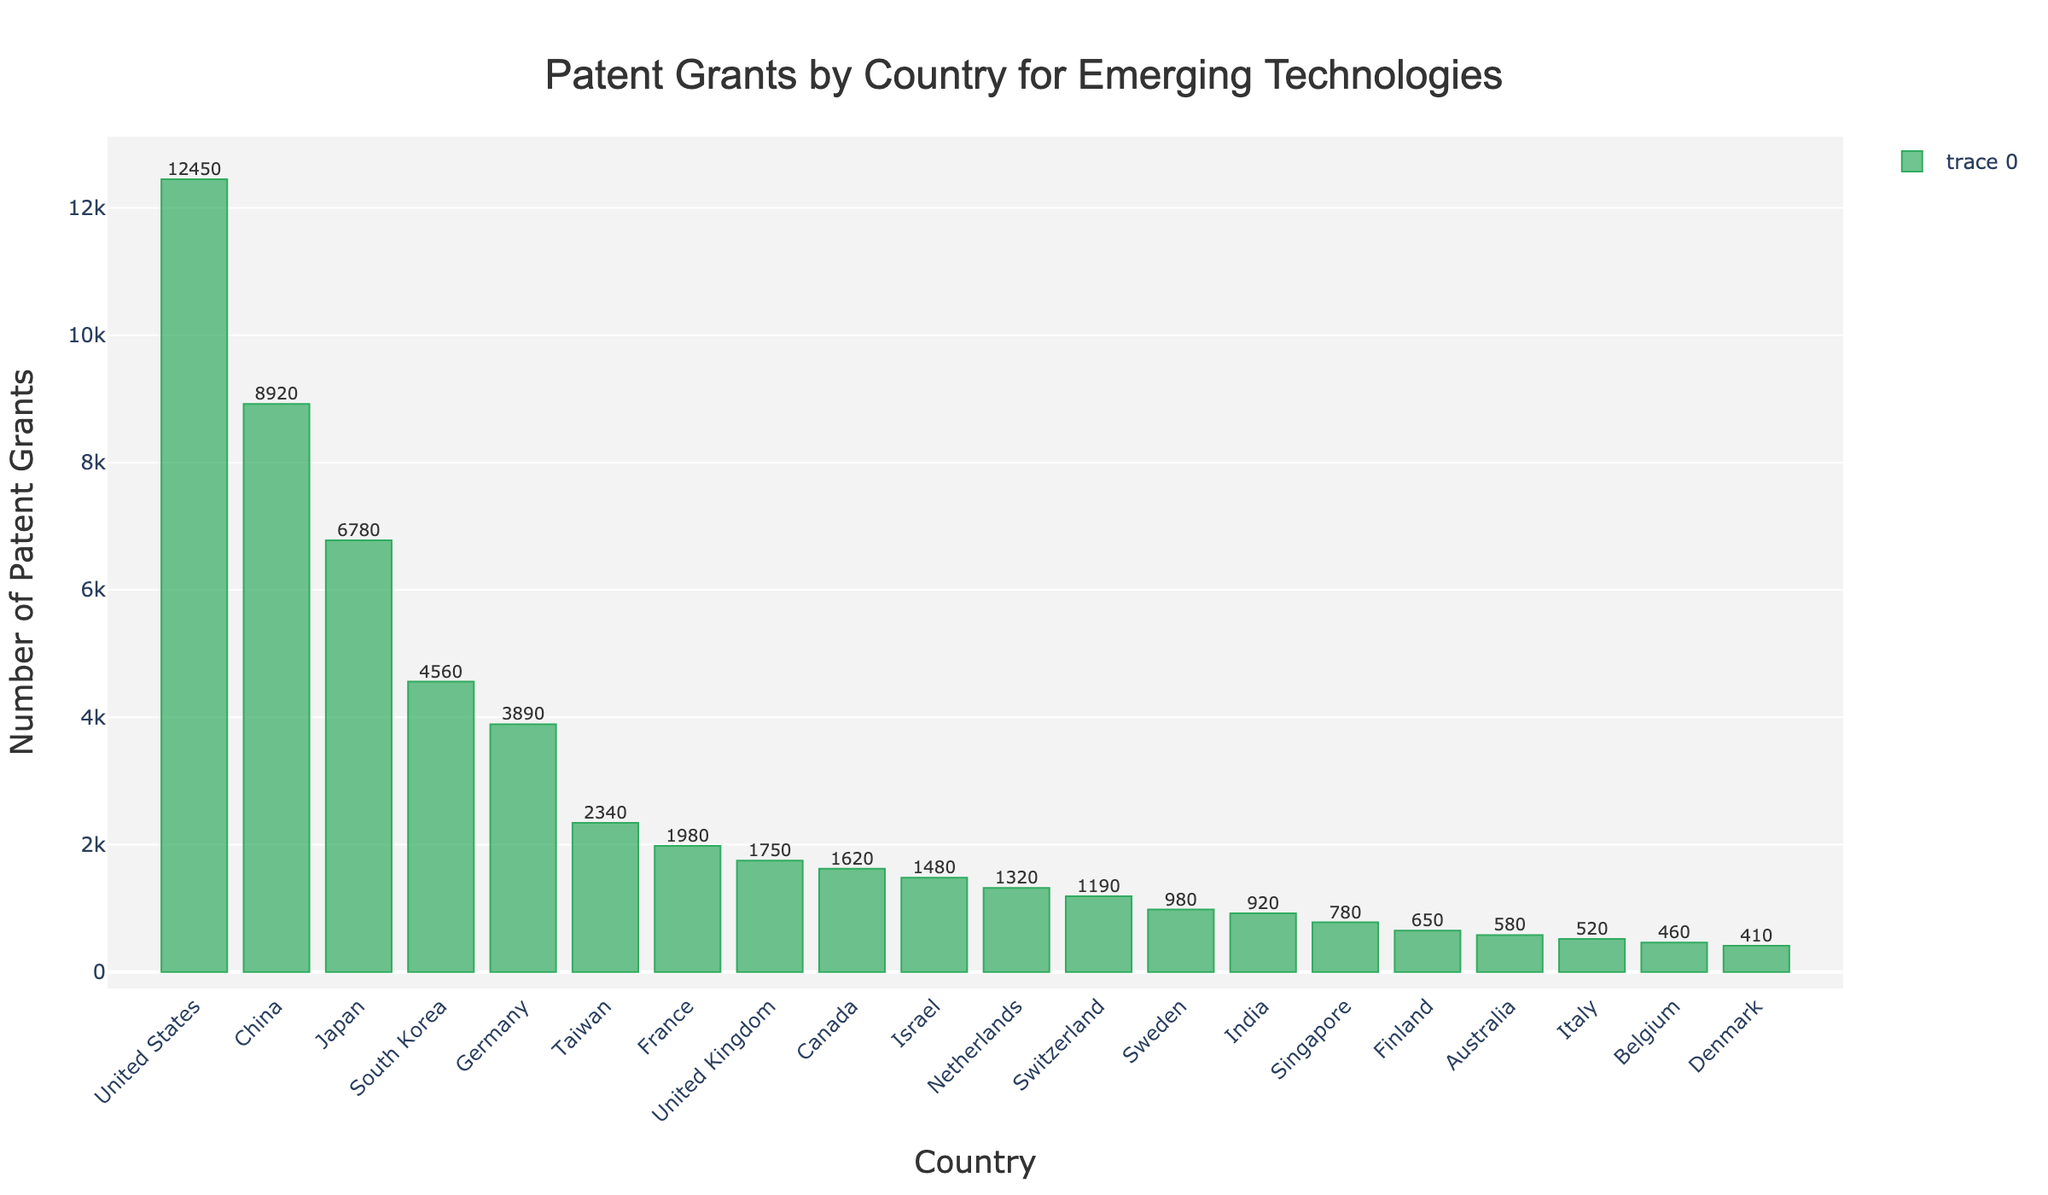Which country has the highest number of patent grants? First, identify the country with the tallest bar. The United States has the tallest bar, which indicates it has the highest number of patent grants.
Answer: United States Which two countries have the closest number of patent grants, and what is the difference? First, identify two countries with bars of nearly equal height. Israel and Netherlands have very close bar heights. Calculate the difference: 1480 - 1320 = 160.
Answer: Israel and Netherlands, 160 What is the total number of patent grants for the top three countries combined? First, identify the top three countries by bar height: United States, China, and Japan. Then add their values: 12450 + 8920 + 6780 = 28150.
Answer: 28150 Which country ranks fifth in terms of the number of patent grants? Rank the countries by the height of their bars. The country with the fifth highest bar is Germany.
Answer: Germany What is the average number of patent grants for European countries listed? Identify the European countries: Germany, France, United Kingdom, Switzerland, Sweden, Finland, Italy, Belgium, and Denmark, and sum their values: 3890 + 1980 + 1750 + 1190 + 980 + 650 + 520 + 460 + 410 = 12830. Divide by the number of countries: 12830 / 9 ≈ 1425.56.
Answer: 1425.56 How many more patent grants does South Korea have compared to India? Identify the bar heights for South Korea and India. Subtract India's value from South Korea's: 4560 - 920 = 3640.
Answer: 3640 Which country has more patent grants: Taiwan or Canada, and by how much? Compare the bar heights of Taiwan and Canada. Taiwan has 2340, and Canada has 1620. Calculate the difference: 2340 - 1620 = 720.
Answer: Taiwan, 720 What is the total number of patent grants for Asian countries listed? Identify the Asian countries: China, Japan, South Korea, Taiwan, Israel, India, and Singapore, and sum their values: 8920 + 6780 + 4560 + 2340 + 1480 + 920 + 780 = 25780.
Answer: 25780 How does the number of patent grants for the United Kingdom compare to that of France? Compare the bar heights of the United Kingdom and France. France has 1980, and the United Kingdom has 1750.
Answer: France has more What percentage of total patent grants do the top five countries collectively account for? First, sum the total number of patent grants for the top five countries: United States, China, Japan, South Korea, and Germany. The sum: 12450 + 8920 + 6780 + 4560 + 3890 = 36600. Then sum the values for all countries: 12450 + 8920 + 6780 + 4560 + 3890 + 2340 + 1980 + 1750 + 1620 + 1480 + 1320 + 1190 + 980 + 920 + 780 + 650 + 580 + 520 + 460 + 410 = 58980. Calculate the percentage: (36600 / 58980) * 100 ≈ 62.05%.
Answer: 62.05% 